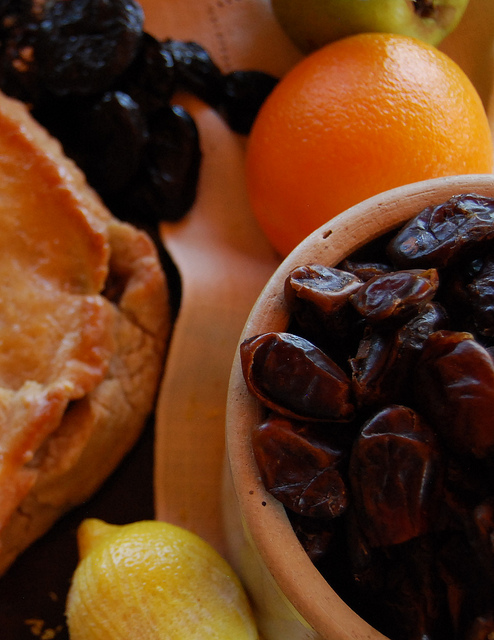<image>Is the bowl made of wood? I'm not sure if the bowl is made of wood. The majority suggests it is, but it could also not be. Is the bowl made of wood? I am not sure if the bowl is made of wood. However, it can be seen that it is made of wood. 